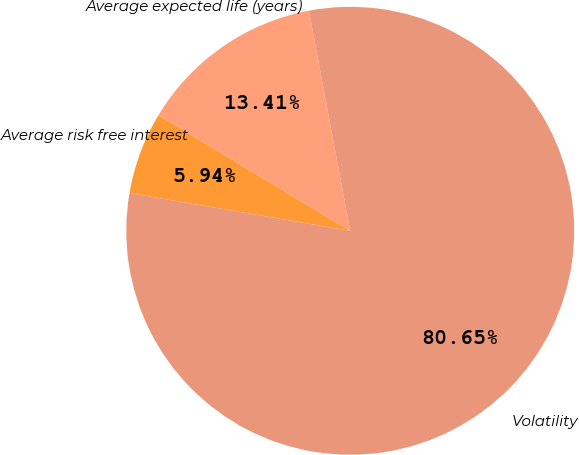<chart> <loc_0><loc_0><loc_500><loc_500><pie_chart><fcel>Average risk free interest<fcel>Average expected life (years)<fcel>Volatility<nl><fcel>5.94%<fcel>13.41%<fcel>80.65%<nl></chart> 